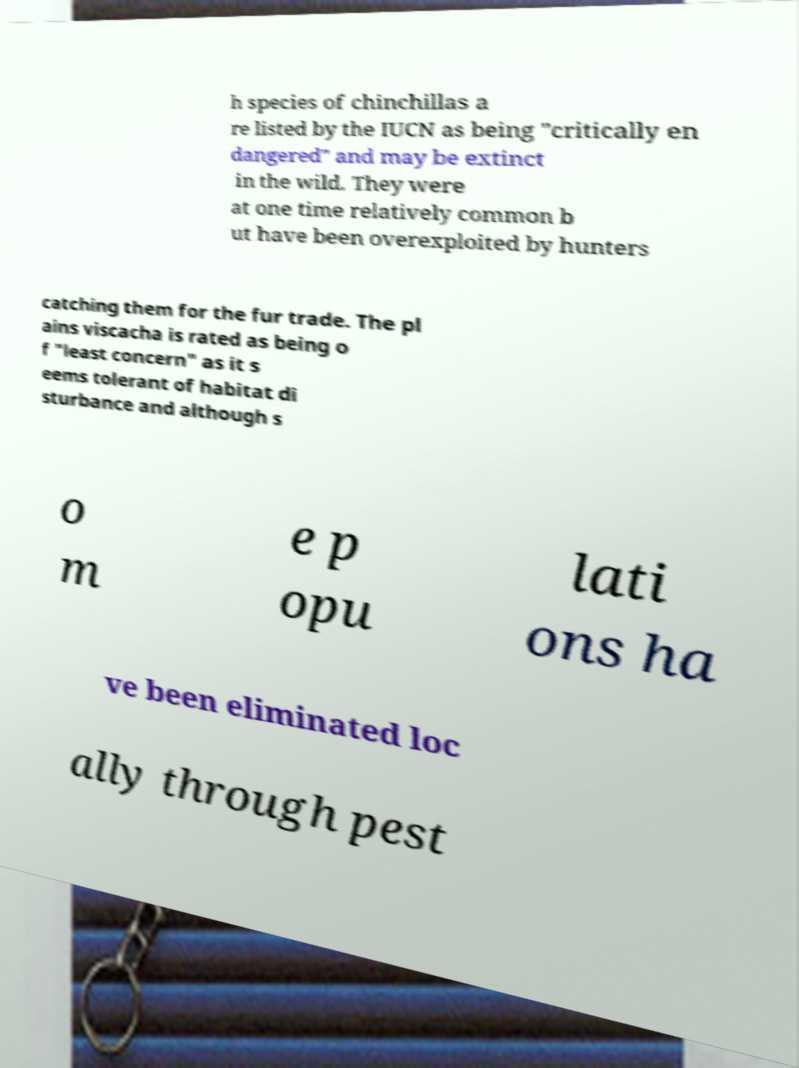Could you assist in decoding the text presented in this image and type it out clearly? h species of chinchillas a re listed by the IUCN as being "critically en dangered" and may be extinct in the wild. They were at one time relatively common b ut have been overexploited by hunters catching them for the fur trade. The pl ains viscacha is rated as being o f "least concern" as it s eems tolerant of habitat di sturbance and although s o m e p opu lati ons ha ve been eliminated loc ally through pest 